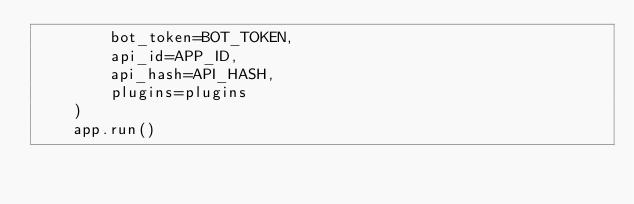Convert code to text. <code><loc_0><loc_0><loc_500><loc_500><_Python_>        bot_token=BOT_TOKEN,
        api_id=APP_ID,
        api_hash=API_HASH,
        plugins=plugins
    )
    app.run()</code> 